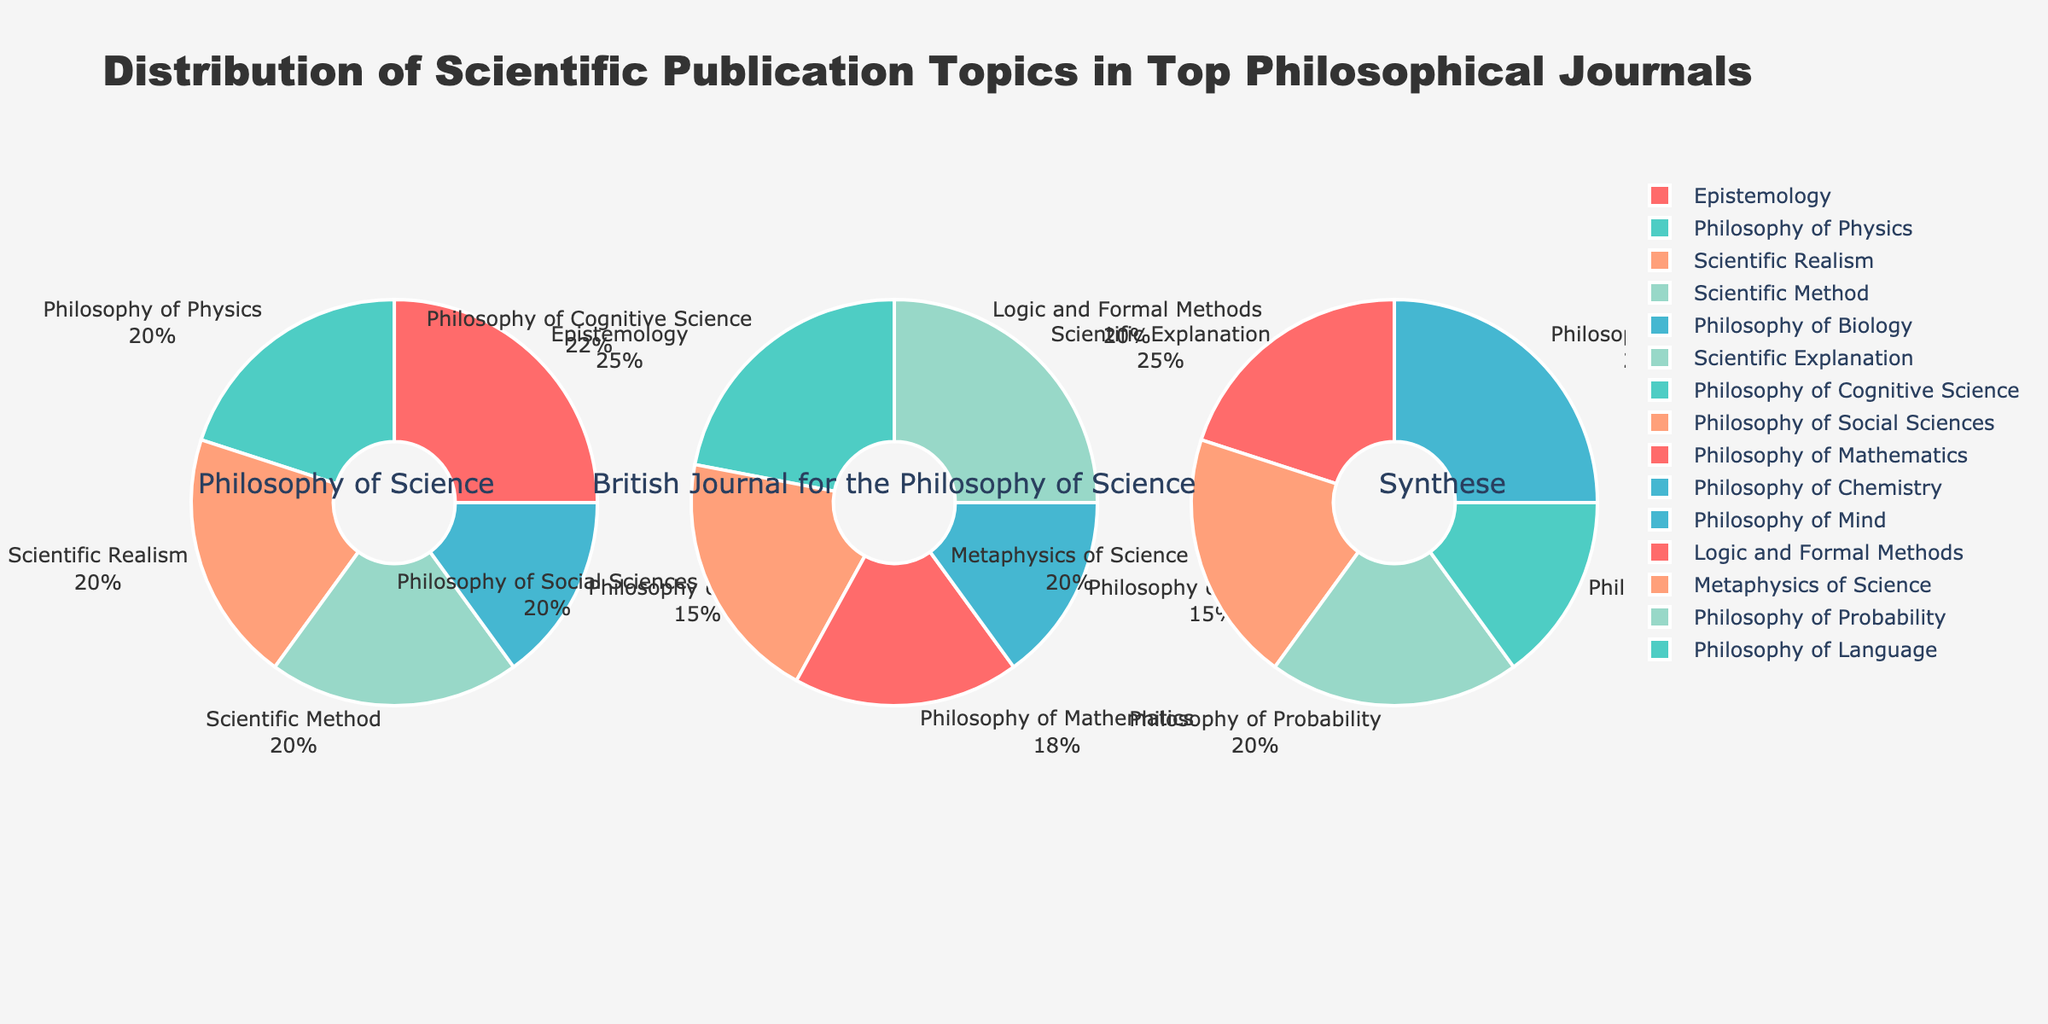What is the title of the figure? The figure's title is located at the top of the plot and is prominently displayed. It reads "Distribution of Scientific Publication Topics in Top Philosophical Journals".
Answer: Distribution of Scientific Publication Topics in Top Philosophical Journals What percentage of publications in the "British Journal for the Philosophy of Science" are dedicated to Philosophy of Cognitive Science? By referring to the pie chart for the "British Journal for the Philosophy of Science," I can see the label "Philosophy of Cognitive Science" with its corresponding percentage. This label shows 22%.
Answer: 22% Which journal has the highest proportion of publications in a single topic, and what is that topic? Looking across all journals, I need to identify the largest percentage listed within each pie chart. "Synthese" has 25% for Philosophy of Mind, and the "British Journal for the Philosophy of Science" also has 25% for Scientific Explanation. Since this value is the highest, the answer is both journals with their respective topics.
Answer: Synthese and British Journal for the Philosophy of Science both have 25% for Philosophy of Mind and Scientific Explanation, respectively How many topics have an exact 20% share in the "Philosophy of Science" journal? By examining the "Philosophy of Science" pie chart, I can see that Philosophy of Physics, Scientific Realism, and Scientific Method all contribute exactly 20% each.
Answer: 3 Which journal has a topic listed as "Scientific Explanation," and what percentage of the journal's publications does this topic represent? Referring to the pie charts, I find that the "British Journal for the Philosophy of Science" lists "Scientific Explanation" as one of its topics, and it makes up 25% of the journal’s publications.
Answer: British Journal for the Philosophy of Science, 25% Combine the percentages of "Philosophy of Physics," "Philosophy of Biology," and "Epistemology" in the "Philosophy of Science" journal. What is the total percentage? I need to sum the values for Philosophy of Physics (20%), Philosophy of Biology (15%), and Epistemology (25%) in the "Philosophy of Science" pie chart. Adding them gives 20 + 15 + 25 = 60%.
Answer: 60% Which journal has the most diverse range of topics based on the number of unique segments in its pie chart? I will count the number of unique topics or segments in each journal's pie chart. "Philosophy of Science" has 5, "British Journal for the Philosophy of Science" has 5, and "Synthese" has 5. All three journals display an equal number of unique segments.
Answer: All journals have an equal number of unique topics Compare the proportion of "Scientific Realism" and "Scientific Method" in the "Philosophy of Science" journal. Are they equal or different? Observing the "Philosophy of Science" pie chart, I notice both "Scientific Realism" and "Scientific Method" have the label showing 20%. Therefore, their proportions are equal.
Answer: Equal 